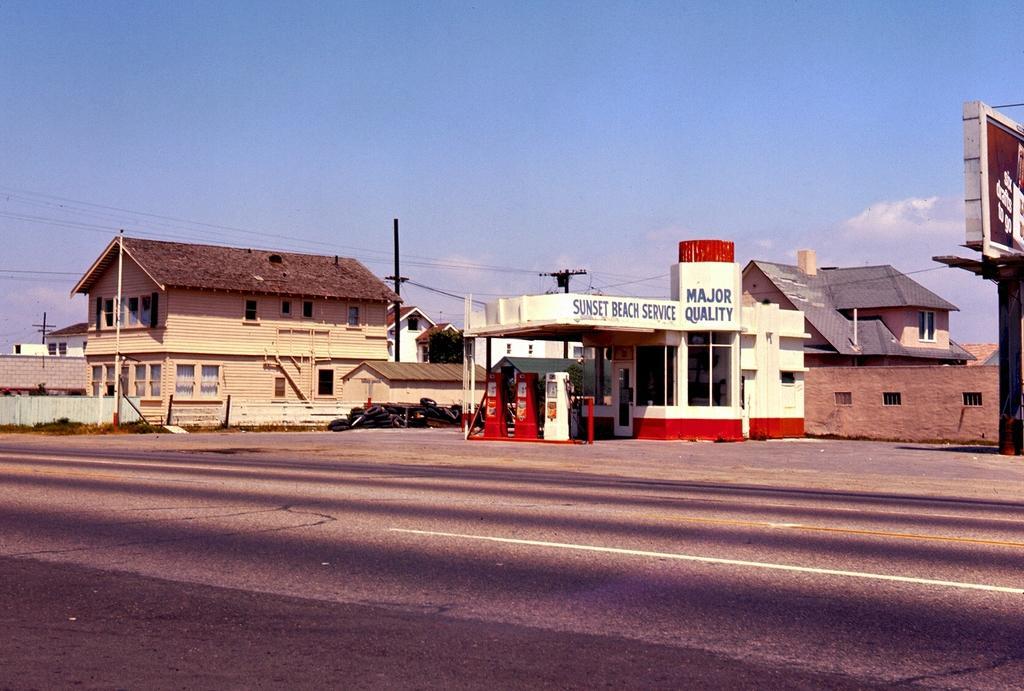Please provide a concise description of this image. In this image there is a road, in the background there is a gas station, houses, current poles and the sky. 